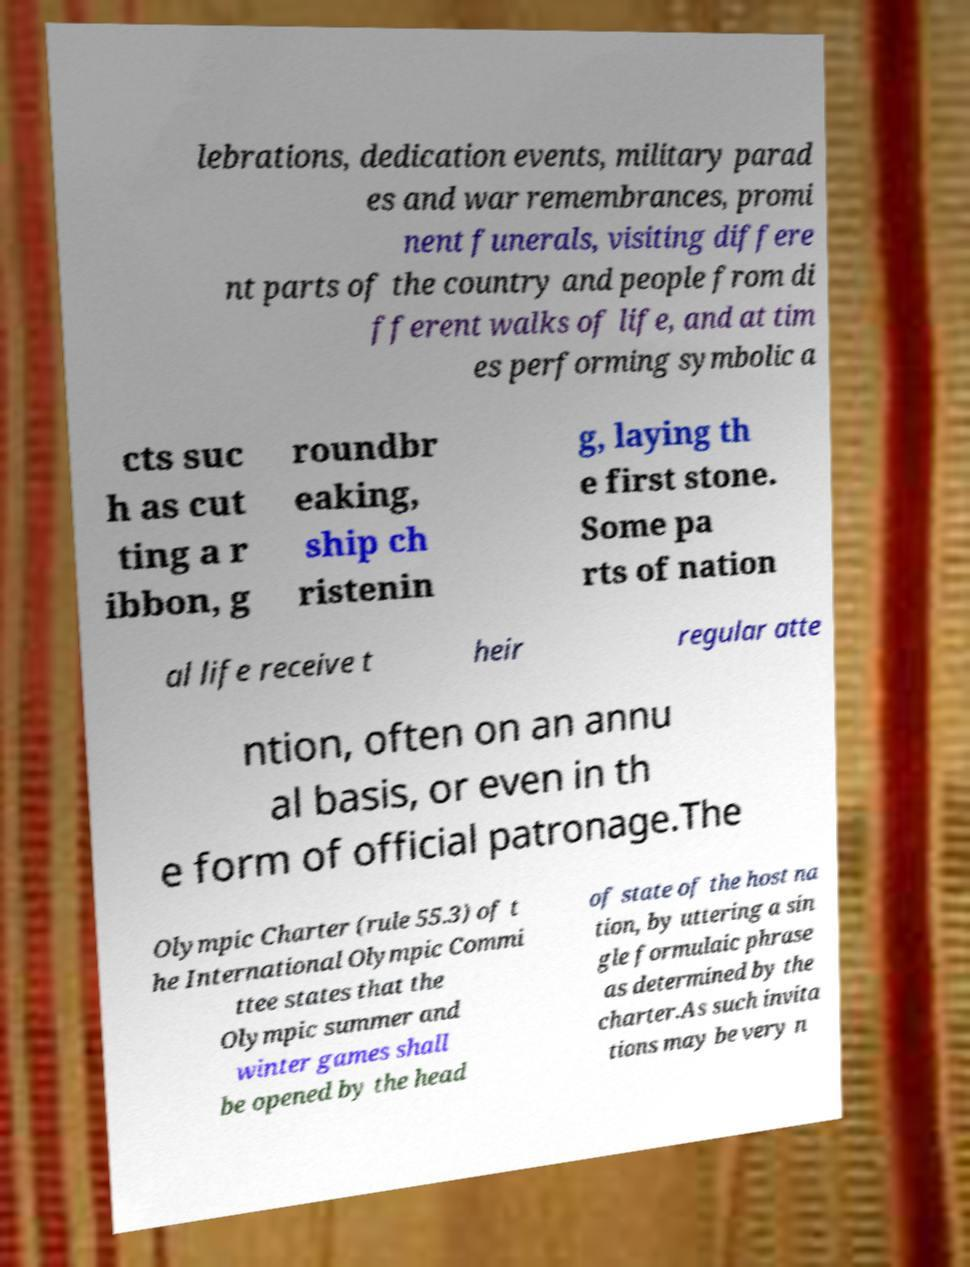For documentation purposes, I need the text within this image transcribed. Could you provide that? lebrations, dedication events, military parad es and war remembrances, promi nent funerals, visiting differe nt parts of the country and people from di fferent walks of life, and at tim es performing symbolic a cts suc h as cut ting a r ibbon, g roundbr eaking, ship ch ristenin g, laying th e first stone. Some pa rts of nation al life receive t heir regular atte ntion, often on an annu al basis, or even in th e form of official patronage.The Olympic Charter (rule 55.3) of t he International Olympic Commi ttee states that the Olympic summer and winter games shall be opened by the head of state of the host na tion, by uttering a sin gle formulaic phrase as determined by the charter.As such invita tions may be very n 